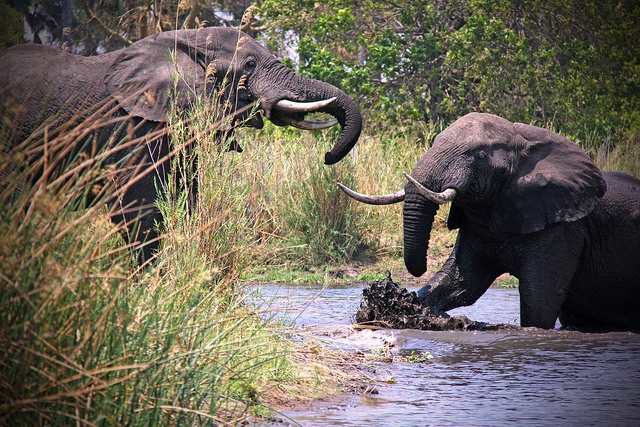Describe the objects in this image and their specific colors. I can see elephant in black, gray, and darkgray tones and elephant in black, gray, and darkgray tones in this image. 